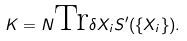Convert formula to latex. <formula><loc_0><loc_0><loc_500><loc_500>K = N \text {Tr} \delta X _ { i } S ^ { \prime } ( \{ X _ { i } \} ) .</formula> 